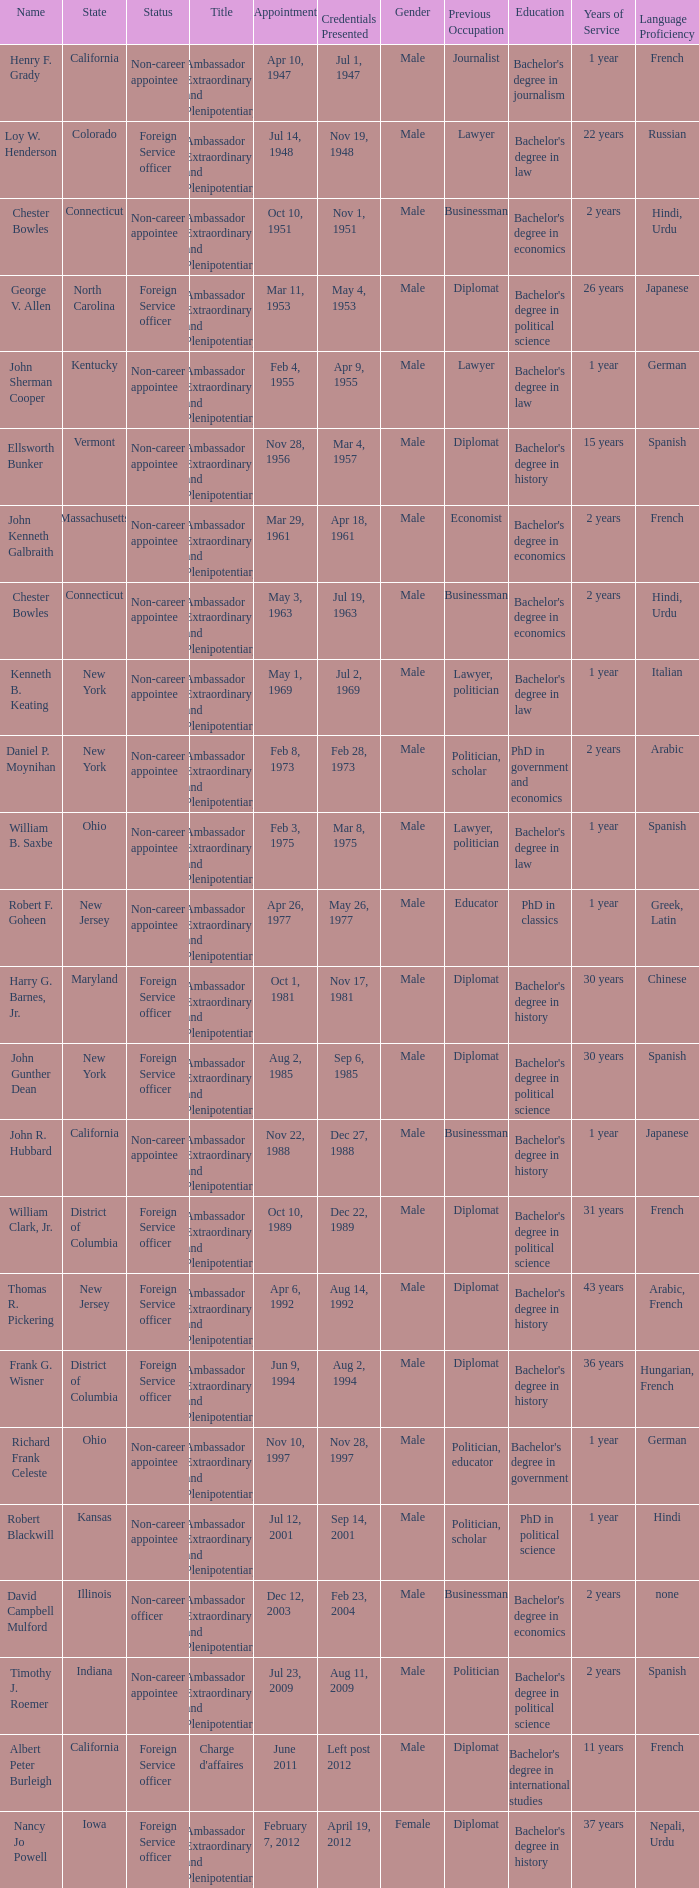When were the credentials presented for new jersey with a status of foreign service officer? Aug 14, 1992. 